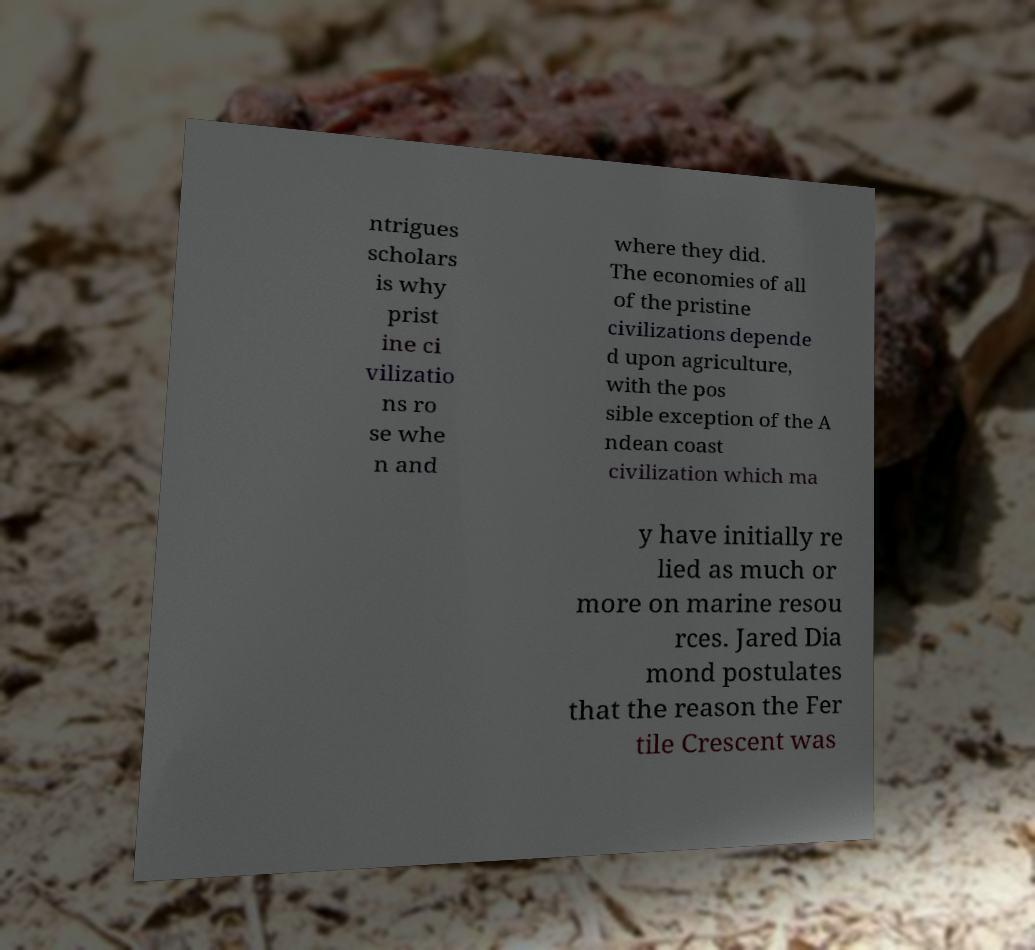Please read and relay the text visible in this image. What does it say? ntrigues scholars is why prist ine ci vilizatio ns ro se whe n and where they did. The economies of all of the pristine civilizations depende d upon agriculture, with the pos sible exception of the A ndean coast civilization which ma y have initially re lied as much or more on marine resou rces. Jared Dia mond postulates that the reason the Fer tile Crescent was 